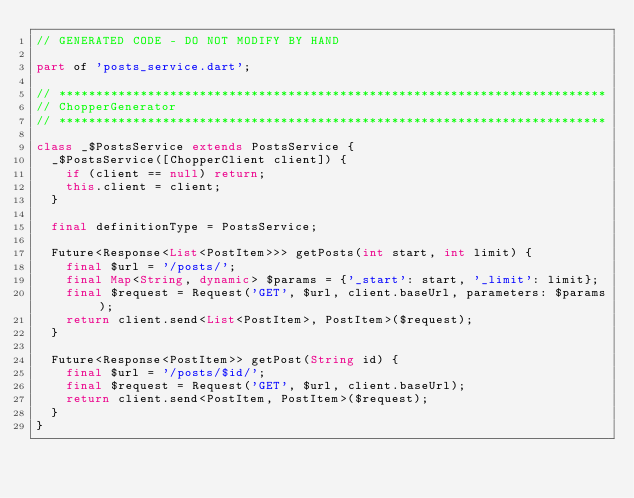<code> <loc_0><loc_0><loc_500><loc_500><_Dart_>// GENERATED CODE - DO NOT MODIFY BY HAND

part of 'posts_service.dart';

// **************************************************************************
// ChopperGenerator
// **************************************************************************

class _$PostsService extends PostsService {
  _$PostsService([ChopperClient client]) {
    if (client == null) return;
    this.client = client;
  }

  final definitionType = PostsService;

  Future<Response<List<PostItem>>> getPosts(int start, int limit) {
    final $url = '/posts/';
    final Map<String, dynamic> $params = {'_start': start, '_limit': limit};
    final $request = Request('GET', $url, client.baseUrl, parameters: $params);
    return client.send<List<PostItem>, PostItem>($request);
  }

  Future<Response<PostItem>> getPost(String id) {
    final $url = '/posts/$id/';
    final $request = Request('GET', $url, client.baseUrl);
    return client.send<PostItem, PostItem>($request);
  }
}
</code> 